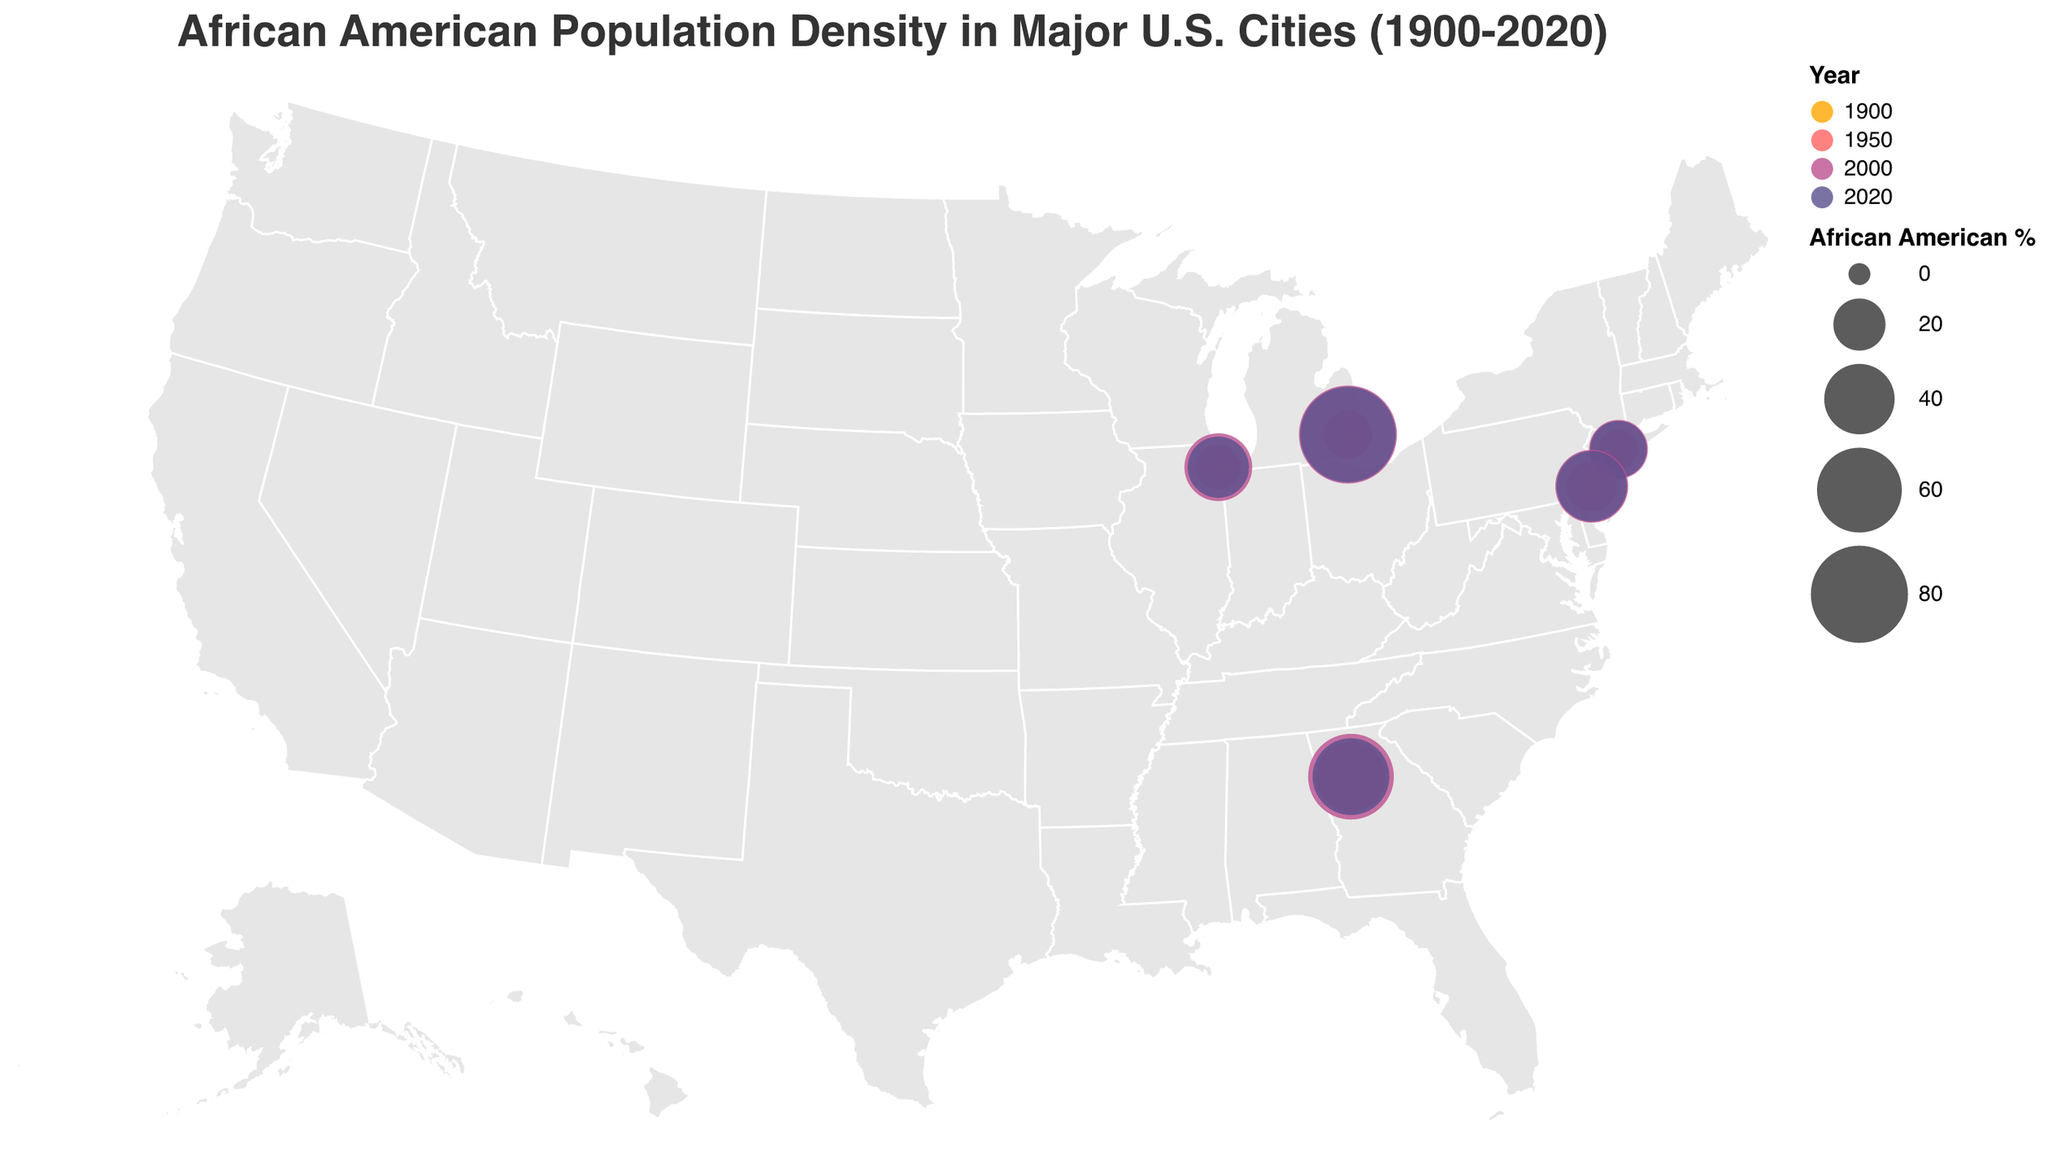What is the title of the figure? The title is displayed prominently at the top of the figure. It serves to introduce the viewer to the content and primary focus of the visualization.
Answer: African American Population Density in Major U.S. Cities (1900-2020) How does the African American population percentage in New York City change between 1900 and 2020? To answer this, you need to locate the data points for New York City at the given years and compare their values.
Answer: It increases from 1.8% in 1900 to 24.3% in 2020 Which city shows the highest percentage of African American population in 2020? To find this, look at the 2020 data points and compare the African American percentages for all the cities.
Answer: Detroit Compare the African American population percentage in Atlanta between 1900 and 2020. Did it increase or decrease? Locate the data points for Atlanta in 1900 and 2020, and compare the values to see the trend.
Answer: Decrease Which two cities show a decrease in African American population percentage from 2000 to 2020? Identify the cities with data points from both 2000 and 2020 and compare the percentages to see which ones decreased.
Answer: Atlanta and New York City What is the change in the African American population percentage in Chicago from 1950 to 2000? Find the data points for Chicago in 1950 and 2000, then subtract the 1950 value from the 2000 value to determine the change.
Answer: Increase from 13.6% to 36.8% Which year shows the highest number of cities with an African American population percentage over 15%? For each year (1900, 1950, 2000, 2020), count the number of cities with percentages over 15% and compare the counts.
Answer: 2000 How does the African American population percentage in Philadelphia compare to that in Detroit in 1950? Locate the data points for both cities in 1950 and compare their values.
Answer: Philadelphia has 18.2%, Detroit has 16.2%. Philadelphia is higher Which city had the lowest percentage of African American population in 1900? Identify the data points for 1900 and compare the percentages to find the lowest value.
Answer: Detroit Among the cities listed, which one shows the least fluctuation in African American population percentage from 1900 to 2020? To determine this, look at the range of percentages for each city from 1900 to 2020 and identify the city with the smallest range.
Answer: New York City 